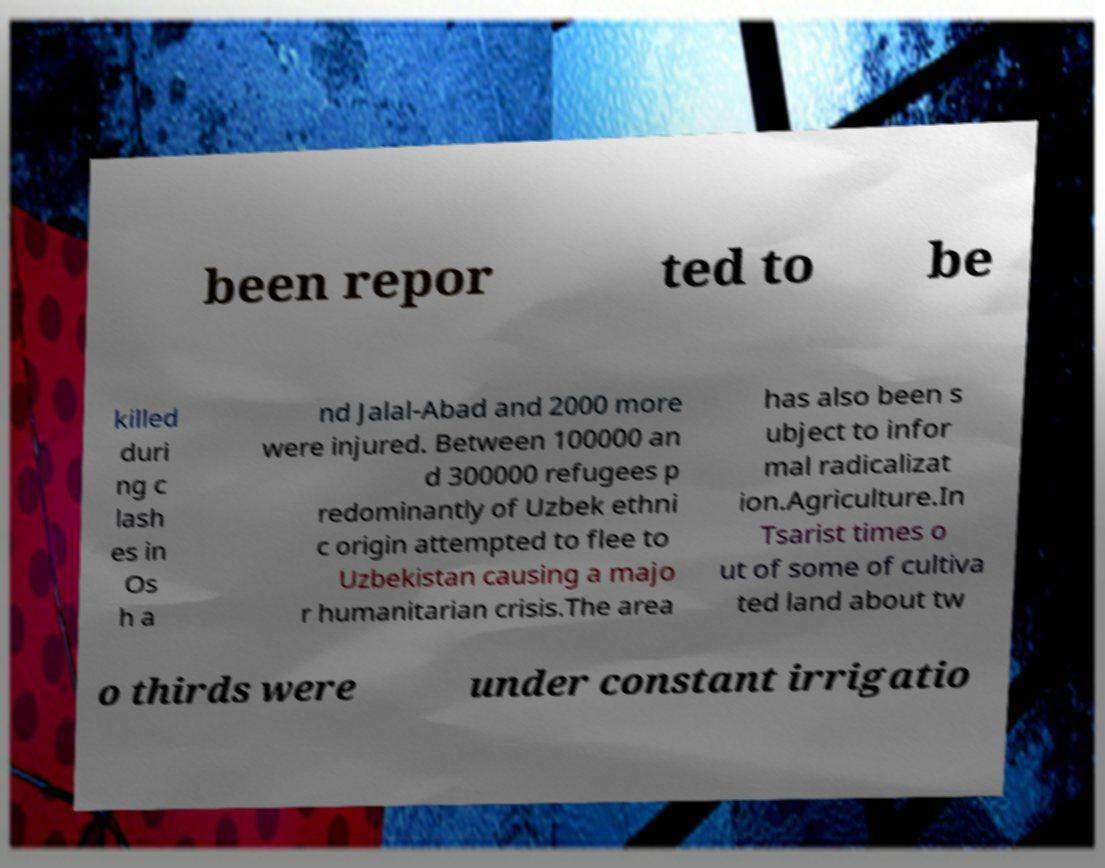What messages or text are displayed in this image? I need them in a readable, typed format. been repor ted to be killed duri ng c lash es in Os h a nd Jalal-Abad and 2000 more were injured. Between 100000 an d 300000 refugees p redominantly of Uzbek ethni c origin attempted to flee to Uzbekistan causing a majo r humanitarian crisis.The area has also been s ubject to infor mal radicalizat ion.Agriculture.In Tsarist times o ut of some of cultiva ted land about tw o thirds were under constant irrigatio 